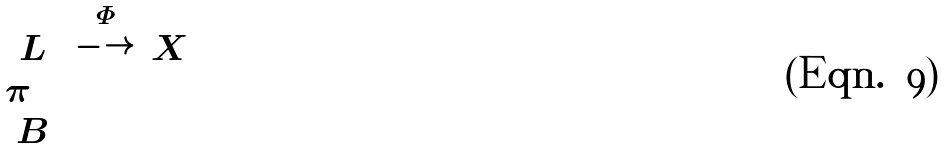<formula> <loc_0><loc_0><loc_500><loc_500>\begin{matrix} & L & \stackrel { \Phi } { \longrightarrow } & X \\ & \pi \downarrow & & \\ & B & & \end{matrix}</formula> 